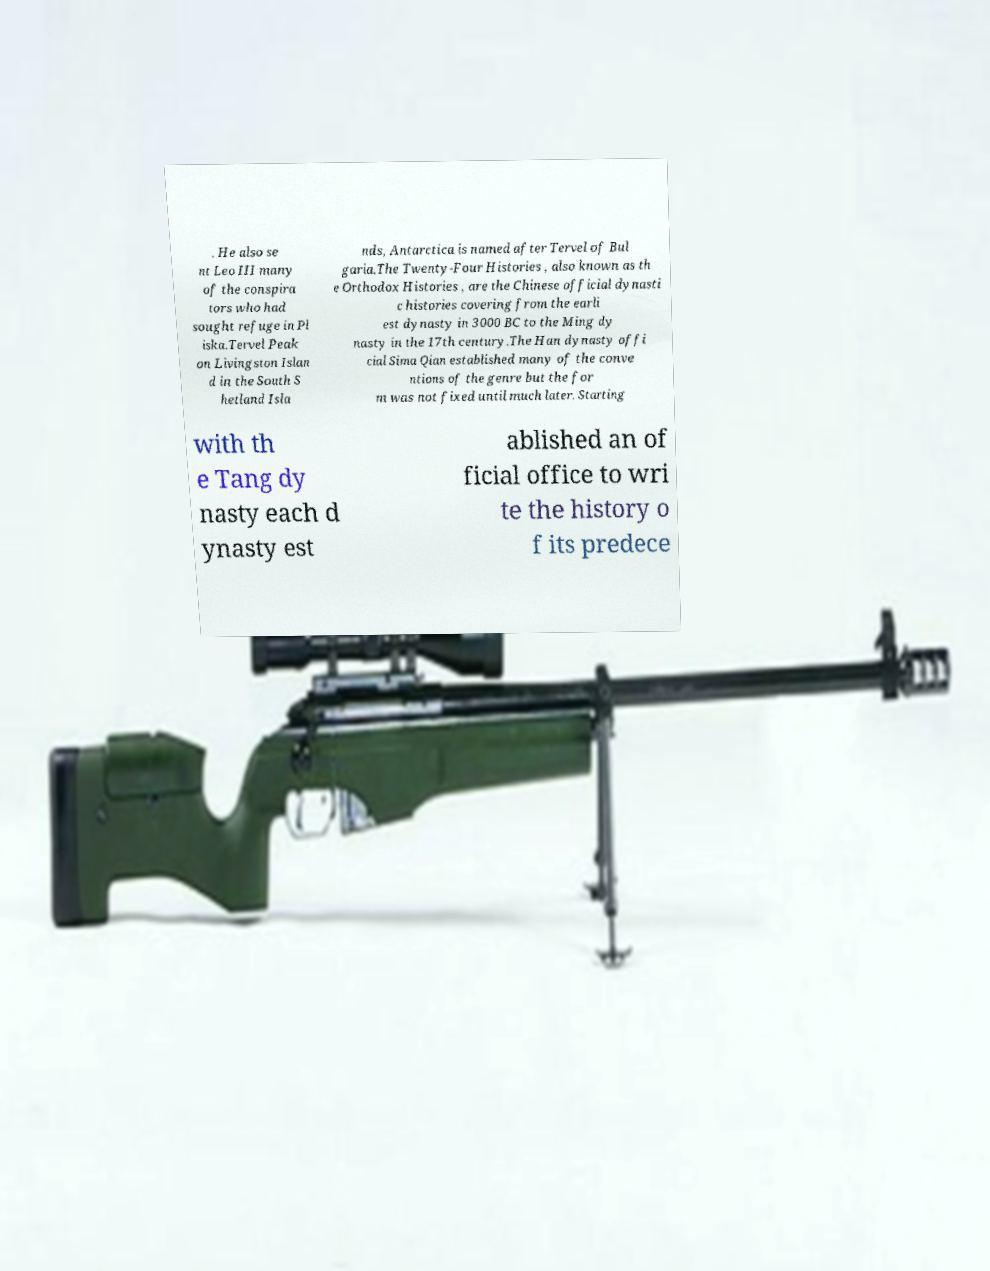Could you extract and type out the text from this image? . He also se nt Leo III many of the conspira tors who had sought refuge in Pl iska.Tervel Peak on Livingston Islan d in the South S hetland Isla nds, Antarctica is named after Tervel of Bul garia.The Twenty-Four Histories , also known as th e Orthodox Histories , are the Chinese official dynasti c histories covering from the earli est dynasty in 3000 BC to the Ming dy nasty in the 17th century.The Han dynasty offi cial Sima Qian established many of the conve ntions of the genre but the for m was not fixed until much later. Starting with th e Tang dy nasty each d ynasty est ablished an of ficial office to wri te the history o f its predece 